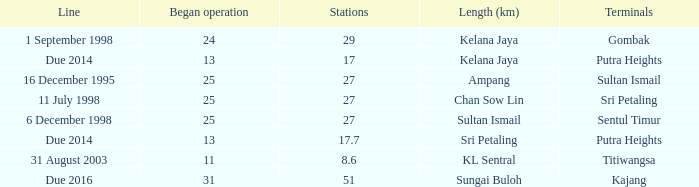Could you parse the entire table as a dict? {'header': ['Line', 'Began operation', 'Stations', 'Length (km)', 'Terminals'], 'rows': [['1 September 1998', '24', '29', 'Kelana Jaya', 'Gombak'], ['Due 2014', '13', '17', 'Kelana Jaya', 'Putra Heights'], ['16 December 1995', '25', '27', 'Ampang', 'Sultan Ismail'], ['11 July 1998', '25', '27', 'Chan Sow Lin', 'Sri Petaling'], ['6 December 1998', '25', '27', 'Sultan Ismail', 'Sentul Timur'], ['Due 2014', '13', '17.7', 'Sri Petaling', 'Putra Heights'], ['31 August 2003', '11', '8.6', 'KL Sentral', 'Titiwangsa'], ['Due 2016', '31', '51', 'Sungai Buloh', 'Kajang']]} What is the average operation beginning with a length of ampang and over 27 stations? None. 